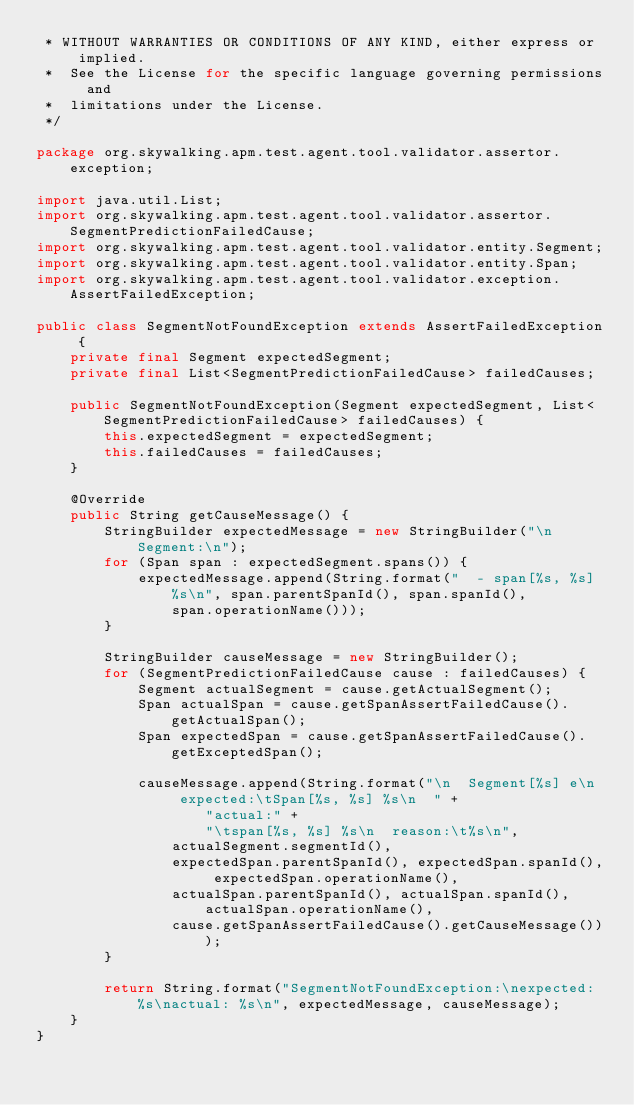<code> <loc_0><loc_0><loc_500><loc_500><_Java_> * WITHOUT WARRANTIES OR CONDITIONS OF ANY KIND, either express or implied.
 *  See the License for the specific language governing permissions and
 *  limitations under the License.
 */

package org.skywalking.apm.test.agent.tool.validator.assertor.exception;

import java.util.List;
import org.skywalking.apm.test.agent.tool.validator.assertor.SegmentPredictionFailedCause;
import org.skywalking.apm.test.agent.tool.validator.entity.Segment;
import org.skywalking.apm.test.agent.tool.validator.entity.Span;
import org.skywalking.apm.test.agent.tool.validator.exception.AssertFailedException;

public class SegmentNotFoundException extends AssertFailedException {
    private final Segment expectedSegment;
    private final List<SegmentPredictionFailedCause> failedCauses;

    public SegmentNotFoundException(Segment expectedSegment, List<SegmentPredictionFailedCause> failedCauses) {
        this.expectedSegment = expectedSegment;
        this.failedCauses = failedCauses;
    }

    @Override
    public String getCauseMessage() {
        StringBuilder expectedMessage = new StringBuilder("\n  Segment:\n");
        for (Span span : expectedSegment.spans()) {
            expectedMessage.append(String.format("  - span[%s, %s] %s\n", span.parentSpanId(), span.spanId(),
                span.operationName()));
        }

        StringBuilder causeMessage = new StringBuilder();
        for (SegmentPredictionFailedCause cause : failedCauses) {
            Segment actualSegment = cause.getActualSegment();
            Span actualSpan = cause.getSpanAssertFailedCause().getActualSpan();
            Span expectedSpan = cause.getSpanAssertFailedCause().getExceptedSpan();

            causeMessage.append(String.format("\n  Segment[%s] e\n  expected:\tSpan[%s, %s] %s\n  " +
                    "actual:" +
                    "\tspan[%s, %s] %s\n  reason:\t%s\n",
                actualSegment.segmentId(),
                expectedSpan.parentSpanId(), expectedSpan.spanId(), expectedSpan.operationName(),
                actualSpan.parentSpanId(), actualSpan.spanId(), actualSpan.operationName(),
                cause.getSpanAssertFailedCause().getCauseMessage()));
        }

        return String.format("SegmentNotFoundException:\nexpected: %s\nactual: %s\n", expectedMessage, causeMessage);
    }
}
</code> 